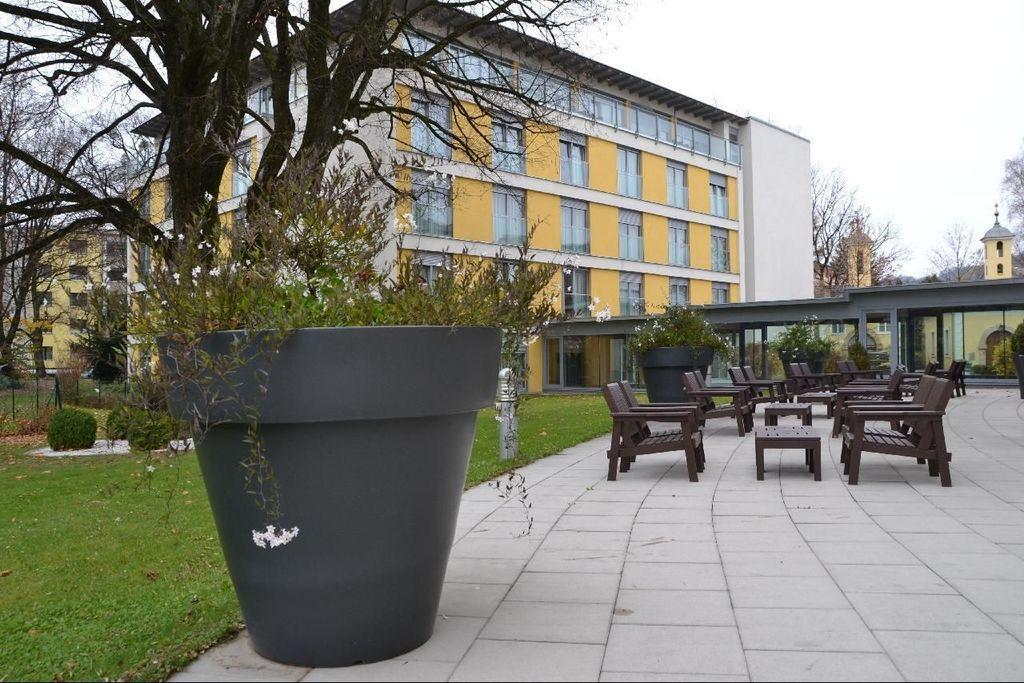Could you give a brief overview of what you see in this image? A plant pot at a garden beside a building. 